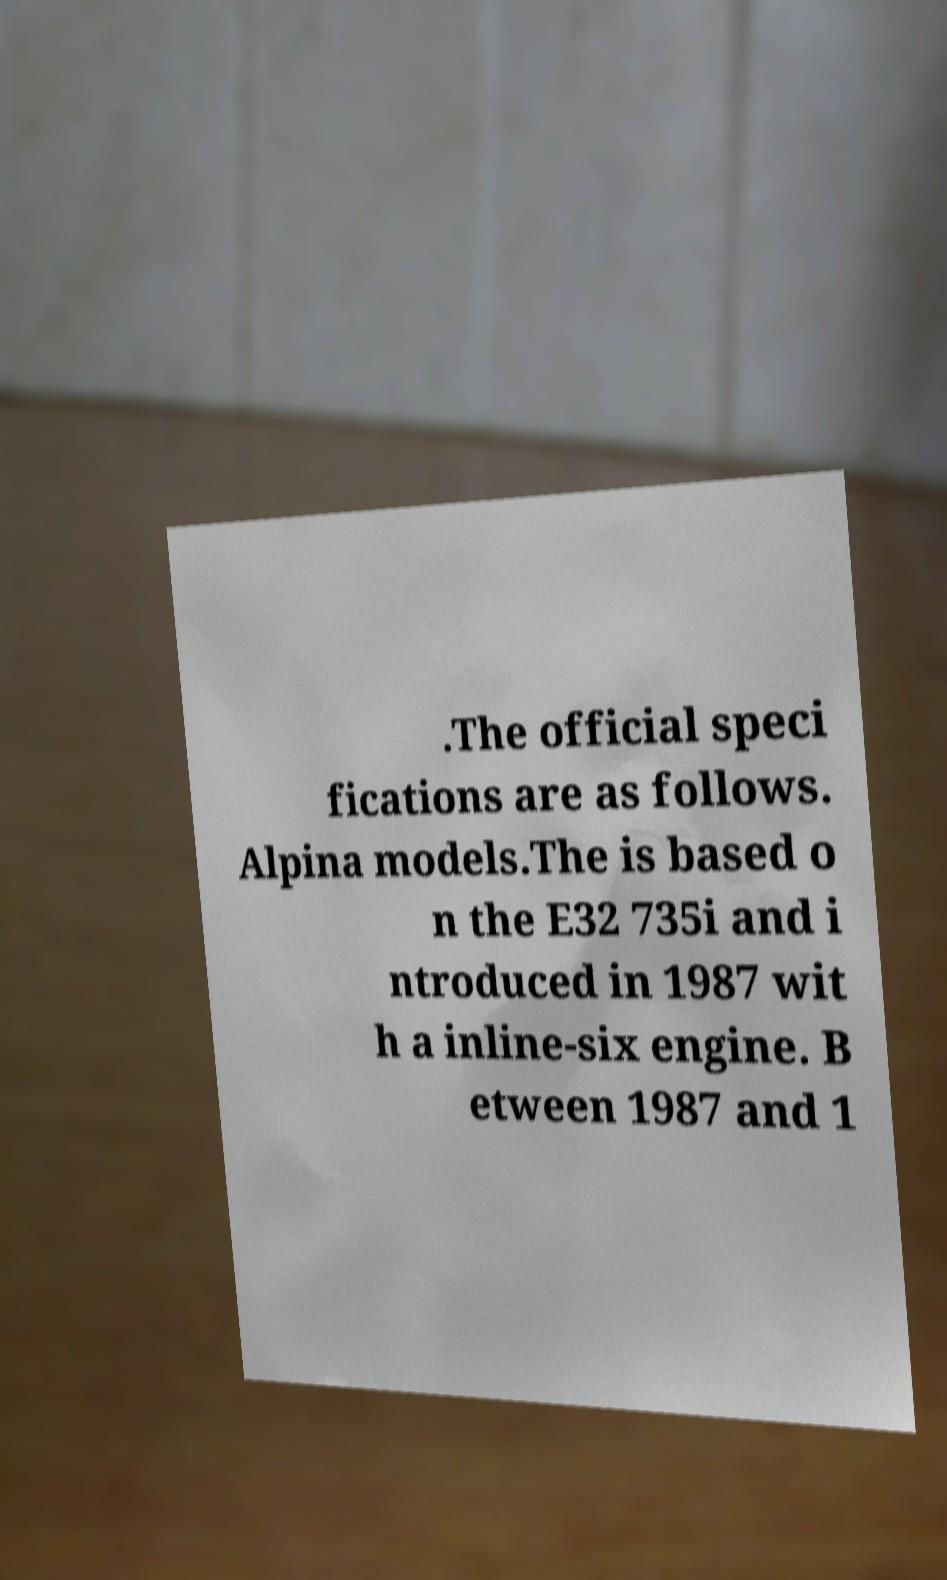What messages or text are displayed in this image? I need them in a readable, typed format. .The official speci fications are as follows. Alpina models.The is based o n the E32 735i and i ntroduced in 1987 wit h a inline-six engine. B etween 1987 and 1 